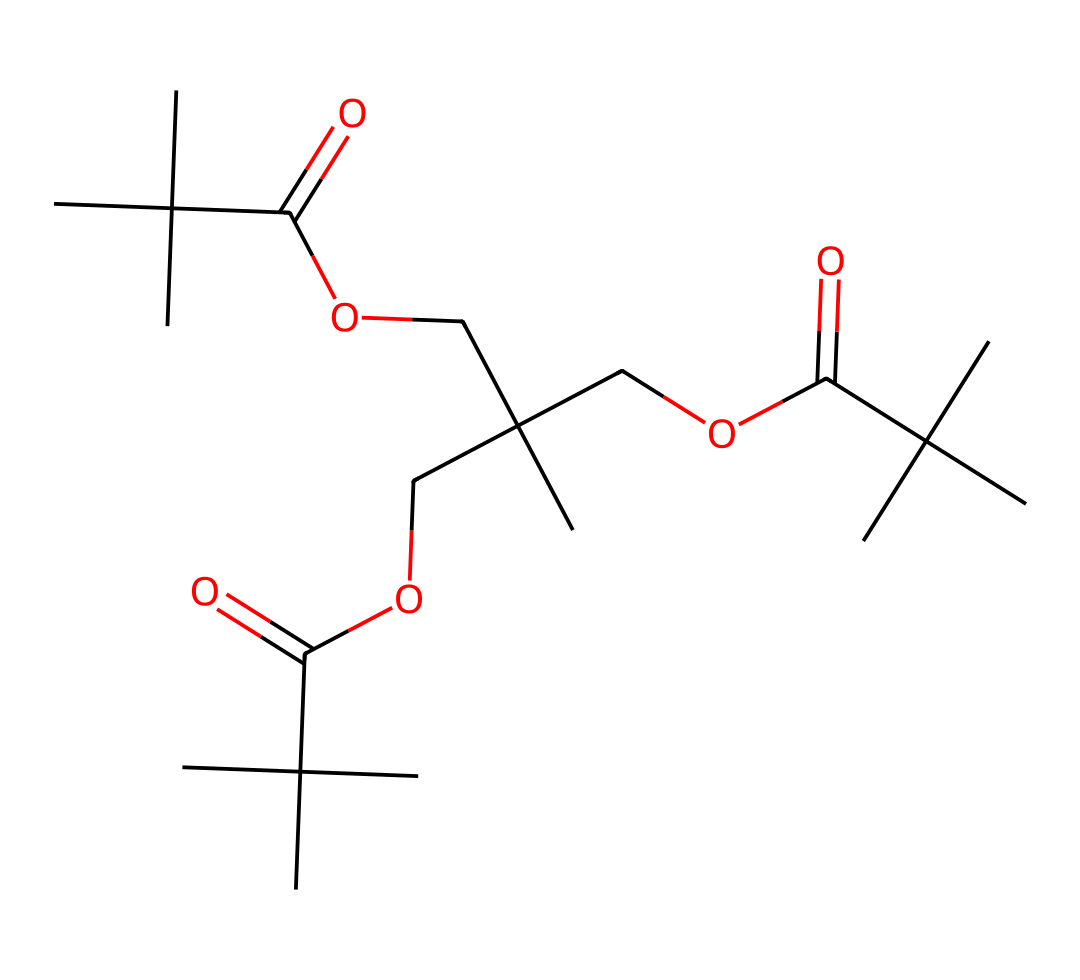What is the main functional group present in this polymer? The polymer has multiple ester linkages indicated by the presence of COO groups in the structure. These groups are characteristic of polyesters, which are formed through the reaction of alcohols and acids.
Answer: ester How many carbon atoms are in the polymer? By analyzing the SMILES representation, we can count the total carbon (C) atoms in the structure. There are 18 carbon atoms present.
Answer: 18 What type of polymer structure is indicated by this SMILES? The presence of repeating ester functional groups in the structure suggests that this polymer is a type of polyester, which is known for its durability and flexibility.
Answer: polyester What is the degree of branching in this polymer? The presence of tert-butyl groups (connected to three methyl groups) in the structure indicates significant branching. This branching contributes to the characteristics of the polymer, making it more flexible and less crystalline.
Answer: significant How many oxygen atoms are present in the polymer? The SMILES shows several COO groups and ether linkages, allowing us to count the oxygen (O) atoms. In total, there are 6 oxygen atoms present.
Answer: 6 What property might this polymer provide to camera lenses? The polymer's structure suggests good optical clarity and resistance to scratches, making it suitable for high-performance applications like camera lenses in digital filmmaking.
Answer: optical clarity 